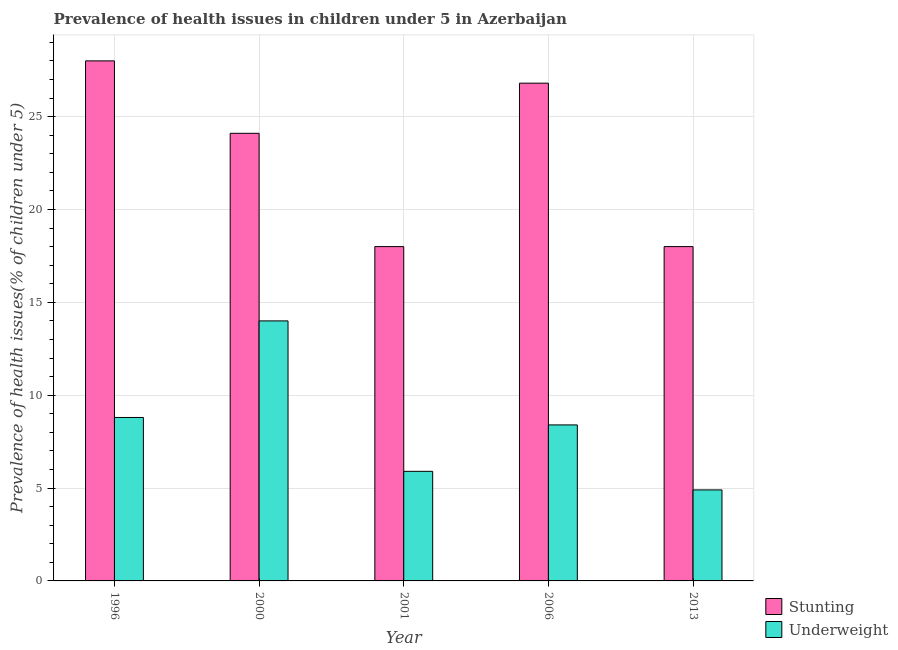How many different coloured bars are there?
Offer a terse response. 2. Are the number of bars per tick equal to the number of legend labels?
Provide a short and direct response. Yes. What is the percentage of underweight children in 1996?
Your answer should be very brief. 8.8. Across all years, what is the maximum percentage of stunted children?
Make the answer very short. 28. Across all years, what is the minimum percentage of stunted children?
Offer a very short reply. 18. In which year was the percentage of underweight children maximum?
Provide a short and direct response. 2000. In which year was the percentage of stunted children minimum?
Your answer should be very brief. 2001. What is the total percentage of underweight children in the graph?
Your response must be concise. 42. What is the difference between the percentage of underweight children in 2000 and that in 2013?
Make the answer very short. 9.1. What is the difference between the percentage of underweight children in 2001 and the percentage of stunted children in 2000?
Provide a short and direct response. -8.1. What is the average percentage of stunted children per year?
Keep it short and to the point. 22.98. In the year 1996, what is the difference between the percentage of underweight children and percentage of stunted children?
Ensure brevity in your answer.  0. What is the ratio of the percentage of stunted children in 2006 to that in 2013?
Give a very brief answer. 1.49. Is the percentage of underweight children in 1996 less than that in 2006?
Keep it short and to the point. No. What is the difference between the highest and the second highest percentage of stunted children?
Provide a short and direct response. 1.2. What is the difference between the highest and the lowest percentage of stunted children?
Provide a short and direct response. 10. What does the 2nd bar from the left in 2000 represents?
Make the answer very short. Underweight. What does the 2nd bar from the right in 2006 represents?
Your answer should be very brief. Stunting. How many bars are there?
Make the answer very short. 10. How many years are there in the graph?
Your answer should be compact. 5. Does the graph contain any zero values?
Keep it short and to the point. No. Where does the legend appear in the graph?
Offer a terse response. Bottom right. How many legend labels are there?
Give a very brief answer. 2. How are the legend labels stacked?
Offer a very short reply. Vertical. What is the title of the graph?
Make the answer very short. Prevalence of health issues in children under 5 in Azerbaijan. Does "Methane" appear as one of the legend labels in the graph?
Your response must be concise. No. What is the label or title of the Y-axis?
Provide a succinct answer. Prevalence of health issues(% of children under 5). What is the Prevalence of health issues(% of children under 5) of Stunting in 1996?
Make the answer very short. 28. What is the Prevalence of health issues(% of children under 5) of Underweight in 1996?
Your response must be concise. 8.8. What is the Prevalence of health issues(% of children under 5) of Stunting in 2000?
Provide a succinct answer. 24.1. What is the Prevalence of health issues(% of children under 5) in Underweight in 2000?
Offer a terse response. 14. What is the Prevalence of health issues(% of children under 5) in Stunting in 2001?
Offer a terse response. 18. What is the Prevalence of health issues(% of children under 5) in Underweight in 2001?
Ensure brevity in your answer.  5.9. What is the Prevalence of health issues(% of children under 5) of Stunting in 2006?
Give a very brief answer. 26.8. What is the Prevalence of health issues(% of children under 5) in Underweight in 2006?
Give a very brief answer. 8.4. What is the Prevalence of health issues(% of children under 5) of Underweight in 2013?
Your answer should be very brief. 4.9. Across all years, what is the maximum Prevalence of health issues(% of children under 5) in Underweight?
Your response must be concise. 14. Across all years, what is the minimum Prevalence of health issues(% of children under 5) of Stunting?
Your answer should be compact. 18. Across all years, what is the minimum Prevalence of health issues(% of children under 5) of Underweight?
Your response must be concise. 4.9. What is the total Prevalence of health issues(% of children under 5) in Stunting in the graph?
Your answer should be compact. 114.9. What is the total Prevalence of health issues(% of children under 5) in Underweight in the graph?
Your answer should be compact. 42. What is the difference between the Prevalence of health issues(% of children under 5) in Underweight in 1996 and that in 2000?
Your answer should be compact. -5.2. What is the difference between the Prevalence of health issues(% of children under 5) in Underweight in 1996 and that in 2001?
Provide a succinct answer. 2.9. What is the difference between the Prevalence of health issues(% of children under 5) of Stunting in 1996 and that in 2006?
Your response must be concise. 1.2. What is the difference between the Prevalence of health issues(% of children under 5) in Stunting in 1996 and that in 2013?
Keep it short and to the point. 10. What is the difference between the Prevalence of health issues(% of children under 5) of Underweight in 2000 and that in 2001?
Offer a very short reply. 8.1. What is the difference between the Prevalence of health issues(% of children under 5) of Stunting in 2000 and that in 2006?
Provide a short and direct response. -2.7. What is the difference between the Prevalence of health issues(% of children under 5) in Underweight in 2001 and that in 2013?
Your response must be concise. 1. What is the difference between the Prevalence of health issues(% of children under 5) in Stunting in 2006 and that in 2013?
Give a very brief answer. 8.8. What is the difference between the Prevalence of health issues(% of children under 5) in Underweight in 2006 and that in 2013?
Your response must be concise. 3.5. What is the difference between the Prevalence of health issues(% of children under 5) of Stunting in 1996 and the Prevalence of health issues(% of children under 5) of Underweight in 2000?
Provide a short and direct response. 14. What is the difference between the Prevalence of health issues(% of children under 5) in Stunting in 1996 and the Prevalence of health issues(% of children under 5) in Underweight in 2001?
Your answer should be compact. 22.1. What is the difference between the Prevalence of health issues(% of children under 5) of Stunting in 1996 and the Prevalence of health issues(% of children under 5) of Underweight in 2006?
Make the answer very short. 19.6. What is the difference between the Prevalence of health issues(% of children under 5) of Stunting in 1996 and the Prevalence of health issues(% of children under 5) of Underweight in 2013?
Your answer should be very brief. 23.1. What is the difference between the Prevalence of health issues(% of children under 5) in Stunting in 2000 and the Prevalence of health issues(% of children under 5) in Underweight in 2006?
Your response must be concise. 15.7. What is the difference between the Prevalence of health issues(% of children under 5) of Stunting in 2001 and the Prevalence of health issues(% of children under 5) of Underweight in 2006?
Your answer should be compact. 9.6. What is the difference between the Prevalence of health issues(% of children under 5) of Stunting in 2001 and the Prevalence of health issues(% of children under 5) of Underweight in 2013?
Keep it short and to the point. 13.1. What is the difference between the Prevalence of health issues(% of children under 5) of Stunting in 2006 and the Prevalence of health issues(% of children under 5) of Underweight in 2013?
Your answer should be compact. 21.9. What is the average Prevalence of health issues(% of children under 5) in Stunting per year?
Your answer should be very brief. 22.98. What is the average Prevalence of health issues(% of children under 5) in Underweight per year?
Make the answer very short. 8.4. In the year 2000, what is the difference between the Prevalence of health issues(% of children under 5) of Stunting and Prevalence of health issues(% of children under 5) of Underweight?
Offer a terse response. 10.1. In the year 2006, what is the difference between the Prevalence of health issues(% of children under 5) of Stunting and Prevalence of health issues(% of children under 5) of Underweight?
Your response must be concise. 18.4. What is the ratio of the Prevalence of health issues(% of children under 5) in Stunting in 1996 to that in 2000?
Offer a terse response. 1.16. What is the ratio of the Prevalence of health issues(% of children under 5) in Underweight in 1996 to that in 2000?
Give a very brief answer. 0.63. What is the ratio of the Prevalence of health issues(% of children under 5) in Stunting in 1996 to that in 2001?
Offer a terse response. 1.56. What is the ratio of the Prevalence of health issues(% of children under 5) of Underweight in 1996 to that in 2001?
Your response must be concise. 1.49. What is the ratio of the Prevalence of health issues(% of children under 5) in Stunting in 1996 to that in 2006?
Your response must be concise. 1.04. What is the ratio of the Prevalence of health issues(% of children under 5) in Underweight in 1996 to that in 2006?
Ensure brevity in your answer.  1.05. What is the ratio of the Prevalence of health issues(% of children under 5) in Stunting in 1996 to that in 2013?
Give a very brief answer. 1.56. What is the ratio of the Prevalence of health issues(% of children under 5) of Underweight in 1996 to that in 2013?
Your answer should be very brief. 1.8. What is the ratio of the Prevalence of health issues(% of children under 5) of Stunting in 2000 to that in 2001?
Provide a short and direct response. 1.34. What is the ratio of the Prevalence of health issues(% of children under 5) in Underweight in 2000 to that in 2001?
Provide a short and direct response. 2.37. What is the ratio of the Prevalence of health issues(% of children under 5) of Stunting in 2000 to that in 2006?
Offer a terse response. 0.9. What is the ratio of the Prevalence of health issues(% of children under 5) of Stunting in 2000 to that in 2013?
Your answer should be compact. 1.34. What is the ratio of the Prevalence of health issues(% of children under 5) of Underweight in 2000 to that in 2013?
Offer a very short reply. 2.86. What is the ratio of the Prevalence of health issues(% of children under 5) in Stunting in 2001 to that in 2006?
Your answer should be very brief. 0.67. What is the ratio of the Prevalence of health issues(% of children under 5) of Underweight in 2001 to that in 2006?
Give a very brief answer. 0.7. What is the ratio of the Prevalence of health issues(% of children under 5) of Stunting in 2001 to that in 2013?
Offer a very short reply. 1. What is the ratio of the Prevalence of health issues(% of children under 5) in Underweight in 2001 to that in 2013?
Make the answer very short. 1.2. What is the ratio of the Prevalence of health issues(% of children under 5) of Stunting in 2006 to that in 2013?
Your answer should be compact. 1.49. What is the ratio of the Prevalence of health issues(% of children under 5) in Underweight in 2006 to that in 2013?
Provide a short and direct response. 1.71. What is the difference between the highest and the second highest Prevalence of health issues(% of children under 5) of Underweight?
Keep it short and to the point. 5.2. What is the difference between the highest and the lowest Prevalence of health issues(% of children under 5) of Stunting?
Offer a very short reply. 10. What is the difference between the highest and the lowest Prevalence of health issues(% of children under 5) in Underweight?
Your response must be concise. 9.1. 